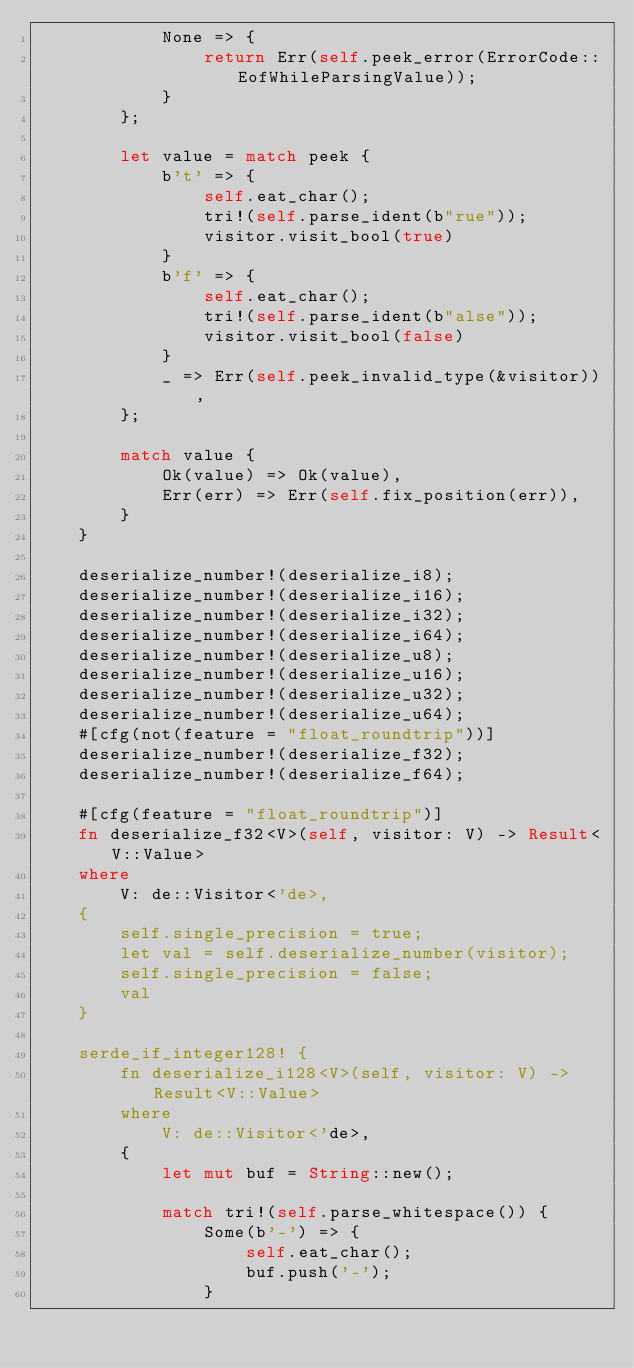Convert code to text. <code><loc_0><loc_0><loc_500><loc_500><_Rust_>            None => {
                return Err(self.peek_error(ErrorCode::EofWhileParsingValue));
            }
        };

        let value = match peek {
            b't' => {
                self.eat_char();
                tri!(self.parse_ident(b"rue"));
                visitor.visit_bool(true)
            }
            b'f' => {
                self.eat_char();
                tri!(self.parse_ident(b"alse"));
                visitor.visit_bool(false)
            }
            _ => Err(self.peek_invalid_type(&visitor)),
        };

        match value {
            Ok(value) => Ok(value),
            Err(err) => Err(self.fix_position(err)),
        }
    }

    deserialize_number!(deserialize_i8);
    deserialize_number!(deserialize_i16);
    deserialize_number!(deserialize_i32);
    deserialize_number!(deserialize_i64);
    deserialize_number!(deserialize_u8);
    deserialize_number!(deserialize_u16);
    deserialize_number!(deserialize_u32);
    deserialize_number!(deserialize_u64);
    #[cfg(not(feature = "float_roundtrip"))]
    deserialize_number!(deserialize_f32);
    deserialize_number!(deserialize_f64);

    #[cfg(feature = "float_roundtrip")]
    fn deserialize_f32<V>(self, visitor: V) -> Result<V::Value>
    where
        V: de::Visitor<'de>,
    {
        self.single_precision = true;
        let val = self.deserialize_number(visitor);
        self.single_precision = false;
        val
    }

    serde_if_integer128! {
        fn deserialize_i128<V>(self, visitor: V) -> Result<V::Value>
        where
            V: de::Visitor<'de>,
        {
            let mut buf = String::new();

            match tri!(self.parse_whitespace()) {
                Some(b'-') => {
                    self.eat_char();
                    buf.push('-');
                }</code> 